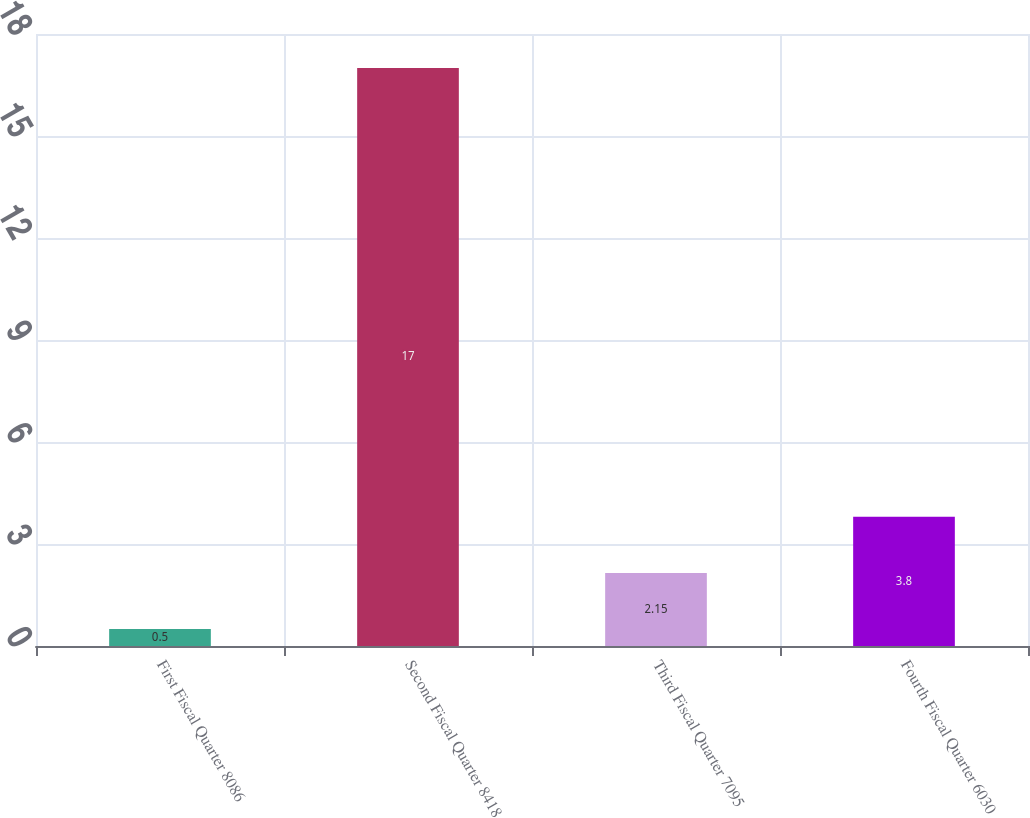Convert chart. <chart><loc_0><loc_0><loc_500><loc_500><bar_chart><fcel>First Fiscal Quarter 8086<fcel>Second Fiscal Quarter 8418<fcel>Third Fiscal Quarter 7095<fcel>Fourth Fiscal Quarter 6030<nl><fcel>0.5<fcel>17<fcel>2.15<fcel>3.8<nl></chart> 